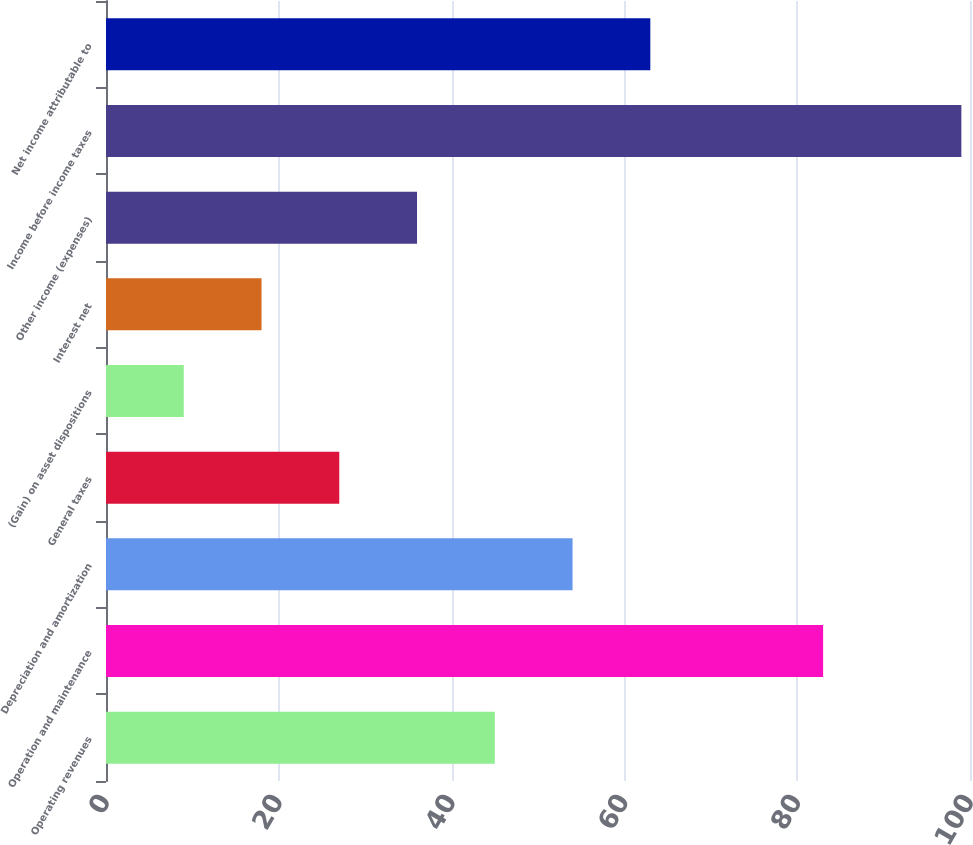<chart> <loc_0><loc_0><loc_500><loc_500><bar_chart><fcel>Operating revenues<fcel>Operation and maintenance<fcel>Depreciation and amortization<fcel>General taxes<fcel>(Gain) on asset dispositions<fcel>Interest net<fcel>Other income (expenses)<fcel>Income before income taxes<fcel>Net income attributable to<nl><fcel>45<fcel>83<fcel>54<fcel>27<fcel>9<fcel>18<fcel>36<fcel>99<fcel>63<nl></chart> 